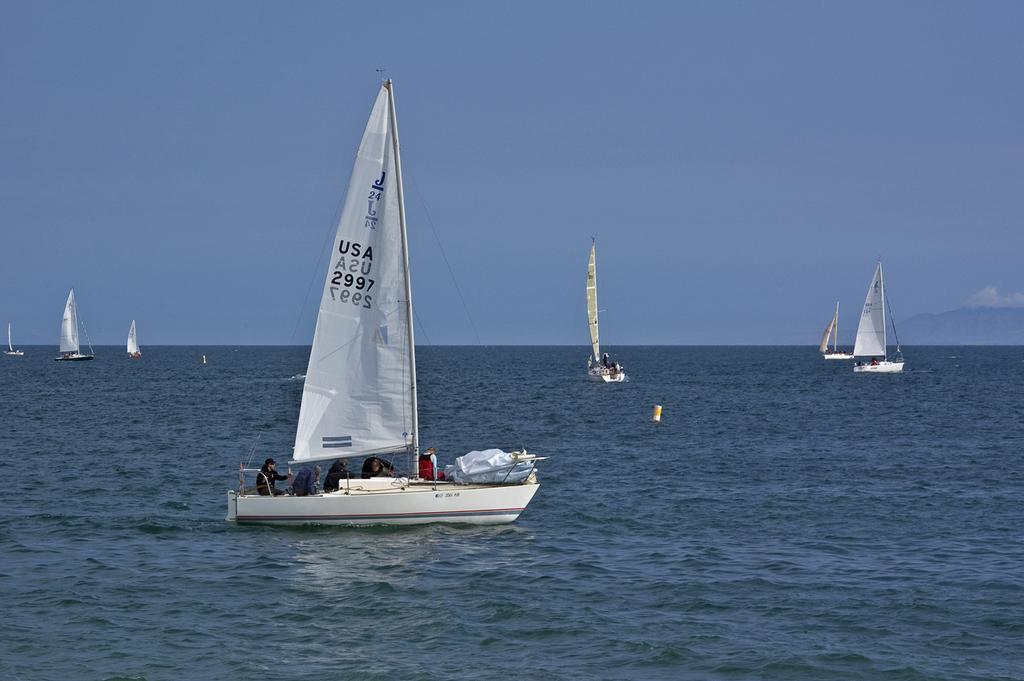Please provide a concise description of this image. In this image we can see a boat in the center. At the bottom of the image there is water. In the background of the image there are boats and sky. 